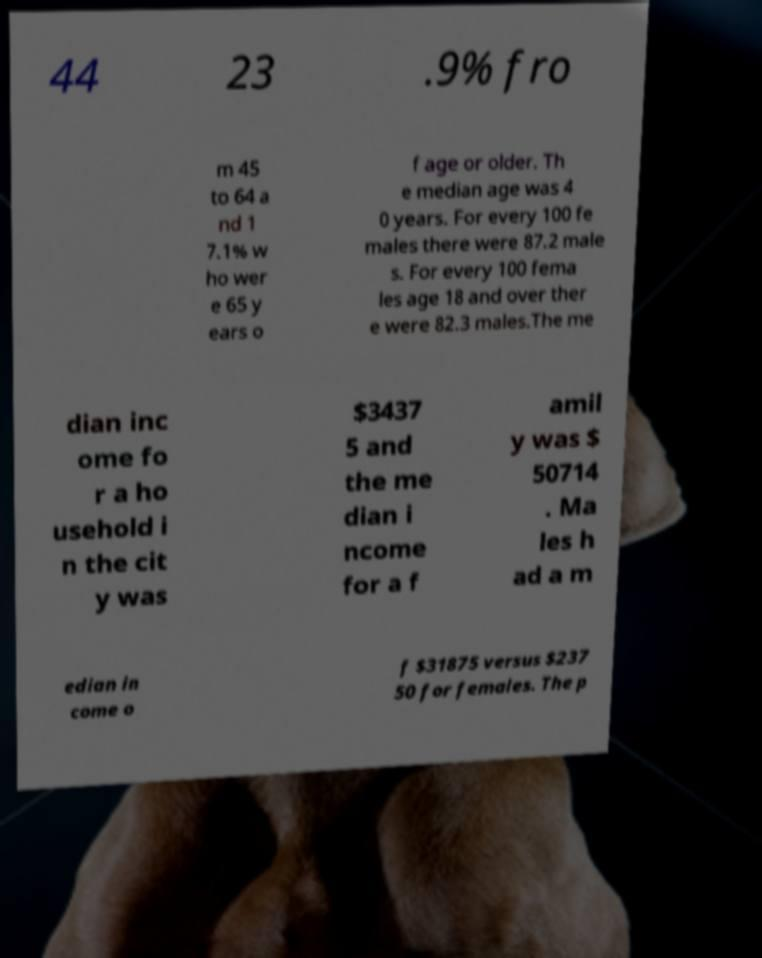What messages or text are displayed in this image? I need them in a readable, typed format. 44 23 .9% fro m 45 to 64 a nd 1 7.1% w ho wer e 65 y ears o f age or older. Th e median age was 4 0 years. For every 100 fe males there were 87.2 male s. For every 100 fema les age 18 and over ther e were 82.3 males.The me dian inc ome fo r a ho usehold i n the cit y was $3437 5 and the me dian i ncome for a f amil y was $ 50714 . Ma les h ad a m edian in come o f $31875 versus $237 50 for females. The p 